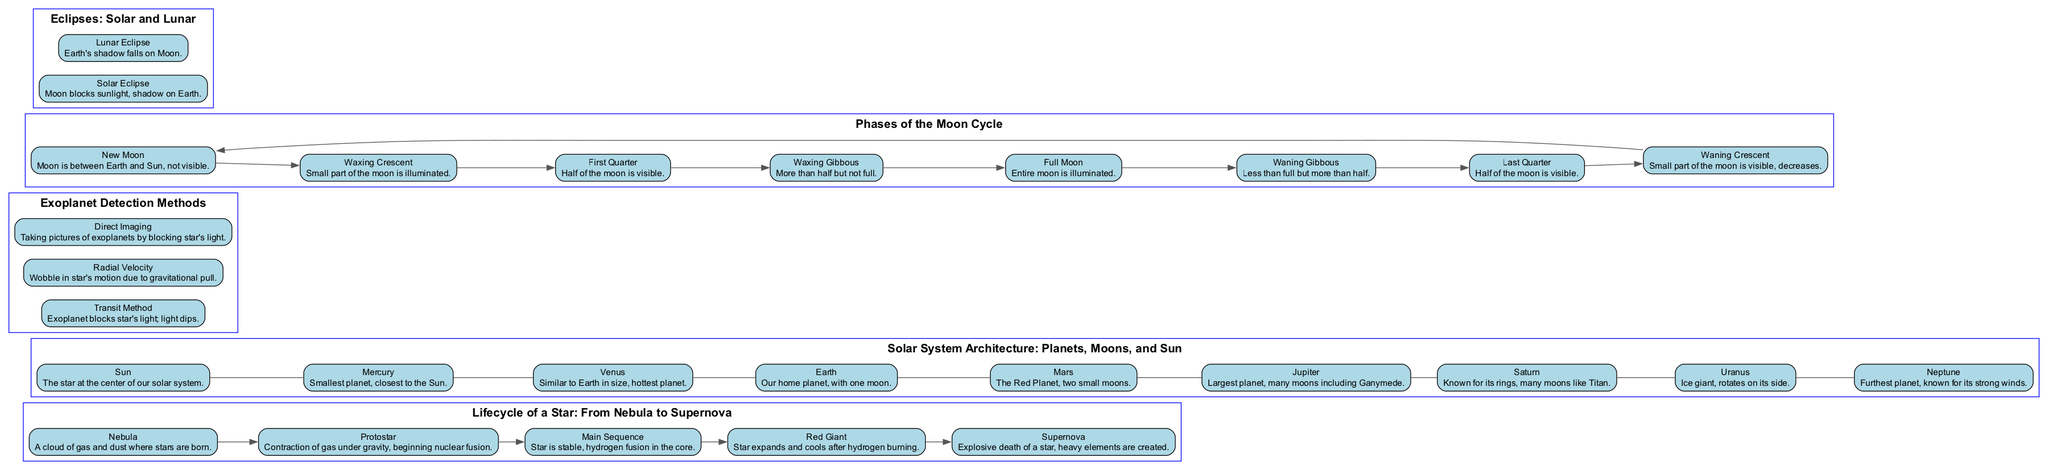What is the first stage in the lifecycle of a star? The diagram shows that the first stage in the lifecycle of a star is the "Nebula." This is indicated as the starting point in the flow of stages shown.
Answer: Nebula How many planets are listed in the Solar System Architecture? The diagram lists a total of 9 bodies, including the Sun and 8 planets. The Sun is included as the central star, making it 9 in total.
Answer: 9 What phase follows the Full Moon in the Moon cycle? According to the phases displayed in the diagram, the phase that follows the Full Moon is "Waning Gibbous." This can be traced by the sequential order of phases presented.
Answer: Waning Gibbous Which method detects exoplanets by observing a star's light dip? The diagram indicates that the "Transit Method" is responsible for detecting exoplanets by observing the light dip when an exoplanet blocks the star's light.
Answer: Transit Method What is the final stage in the lifecycle of a star? The diagram illustrates that the final stage in the lifecycle of a star is the "Supernova." It is the last in the sequence of stages before the star's explosive death.
Answer: Supernova Which planet is known for having rings? In the Solar System Architecture section, the "Saturn" is mentioned as the planet known for its rings, making it easily identifiable.
Answer: Saturn What is the description of a Lunar Eclipse? The diagram describes a Lunar Eclipse as occurring when the "Earth's shadow falls on Moon." This can be found within the section that differentiates between solar and lunar eclipses.
Answer: Earth's shadow falls on Moon Identify one exoplanet detection method associated with star wobble. The "Radial Velocity" method is mentioned in the diagram as the one associated with detecting the wobble in a star's motion due to gravitational pull from an exoplanet.
Answer: Radial Velocity What is the first phase of the Moon according to the diagram? The diagram shows the "New Moon" as the first phase in the Moon cycle, which is illustrated at the start of the list of phases.
Answer: New Moon 